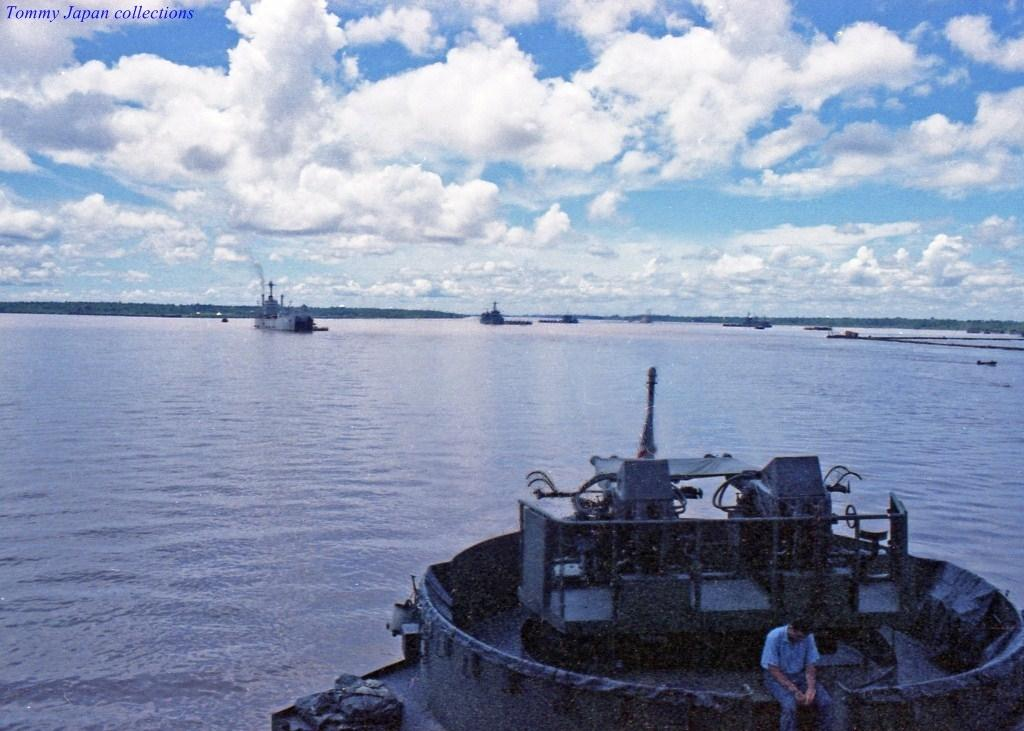What is the main subject in the foreground of the image? There is a man sitting on a ship in the foreground of the image. What else can be seen on the water in the image? There are ships visible on the water in the background of the image. What is visible in the sky in the image? The sky is visible in the background of the image, and there are clouds in the sky. What type of song is the man singing on the ship in the image? There is no indication in the image that the man is singing a song, so it cannot be determined from the picture. 